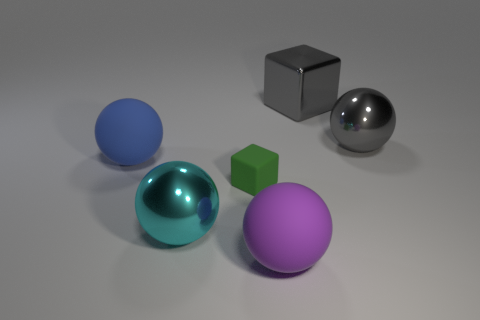Do the gray block and the large ball to the right of the purple thing have the same material?
Your response must be concise. Yes. Are there an equal number of big blocks that are behind the large cyan sphere and cyan matte objects?
Make the answer very short. No. What color is the cube on the left side of the purple sphere?
Provide a short and direct response. Green. What number of other objects are the same color as the metallic cube?
Provide a succinct answer. 1. Is there any other thing that is the same size as the green matte cube?
Offer a very short reply. No. There is a gray shiny object that is in front of the gray metallic cube; is its size the same as the tiny block?
Keep it short and to the point. No. What material is the block that is left of the big shiny block?
Make the answer very short. Rubber. How many rubber objects are either balls or gray cubes?
Make the answer very short. 2. Is the number of purple balls that are left of the large cyan metallic object less than the number of gray blocks?
Give a very brief answer. Yes. What shape is the small green matte thing on the right side of the metallic ball that is in front of the gray shiny object that is in front of the metal block?
Your answer should be very brief. Cube. 